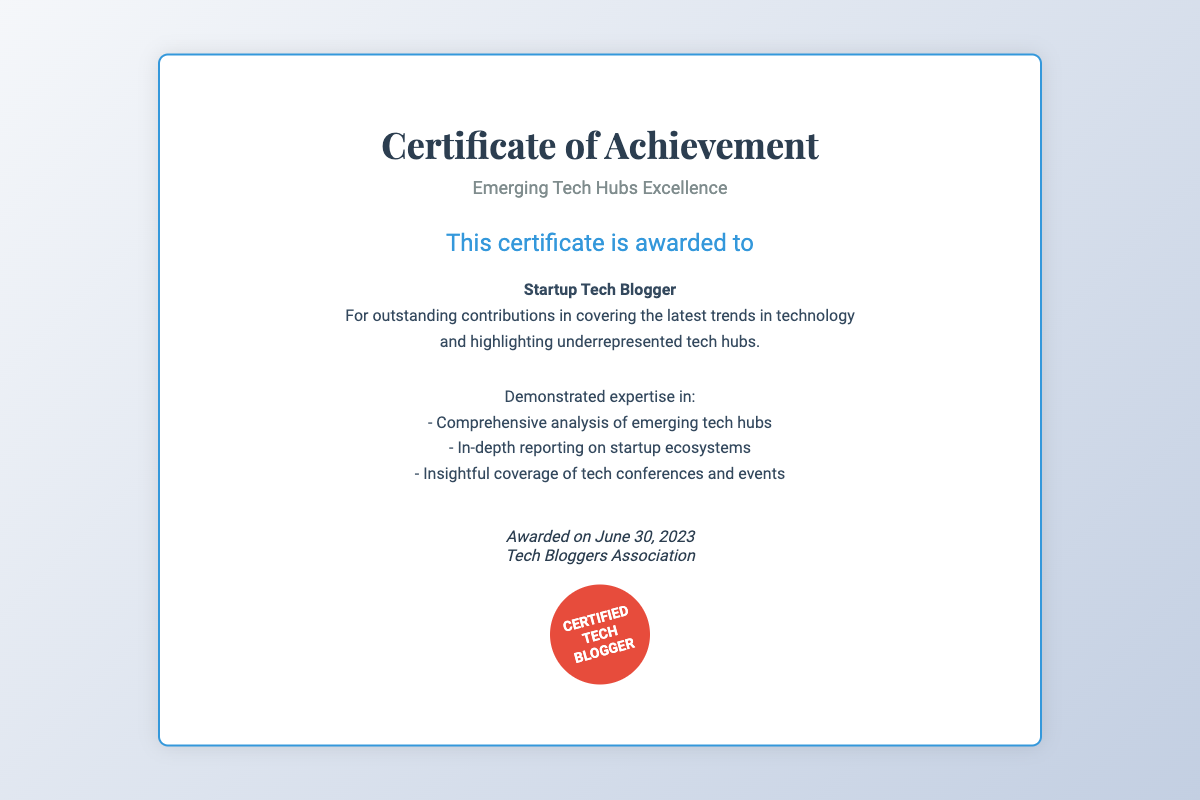What is the title of the document? The title of the document is prominently displayed at the top and indicates the subject matter.
Answer: Certificate of Achievement Who is awarded the certificate? The recipient of the certificate is clearly stated in the details section.
Answer: Startup Tech Blogger What is the award date on the document? The date awarded is mentioned in the signature section.
Answer: June 30, 2023 What organization awarded the certificate? The entity that issued the certificate is listed in the signature area.
Answer: Tech Bloggers Association What are the highlighted contributions of the recipient? The document specifies the contributions made by the recipient in a detailed manner.
Answer: Covering the latest trends in technology and highlighting underrepresented tech hubs What type of excellence does the certificate represent? The theme of the certificate is described in the subtitle of the document.
Answer: Emerging Tech Hubs Excellence What is the purpose of demonstrating expertise? The expertise mentioned relates to a specific focus within the tech blogging community.
Answer: Analysis of emerging tech hubs What visual element is included on the certificate? The design includes an eye-catching feature that signifies certified status.
Answer: Seal 